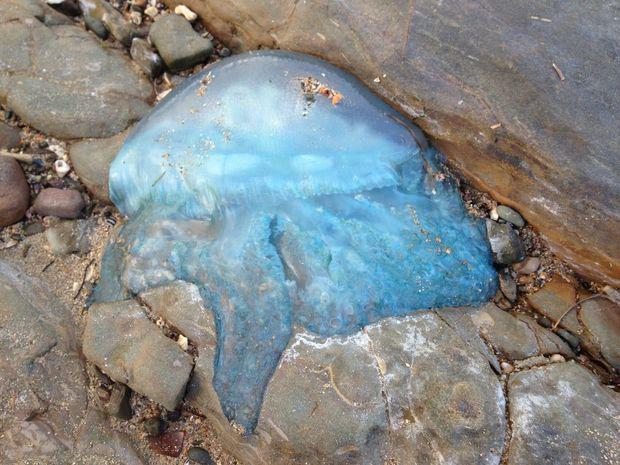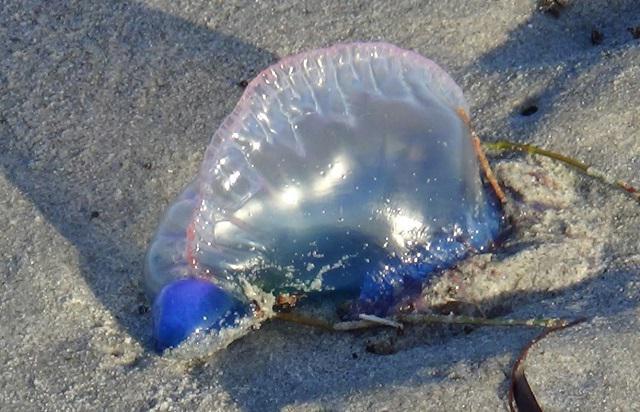The first image is the image on the left, the second image is the image on the right. For the images shown, is this caption "Each image shows one prominent beached jellyfish that resembles an inflated bluish translucent balloon." true? Answer yes or no. Yes. The first image is the image on the left, the second image is the image on the right. For the images displayed, is the sentence "Each picture only has one jellyfish." factually correct? Answer yes or no. Yes. 